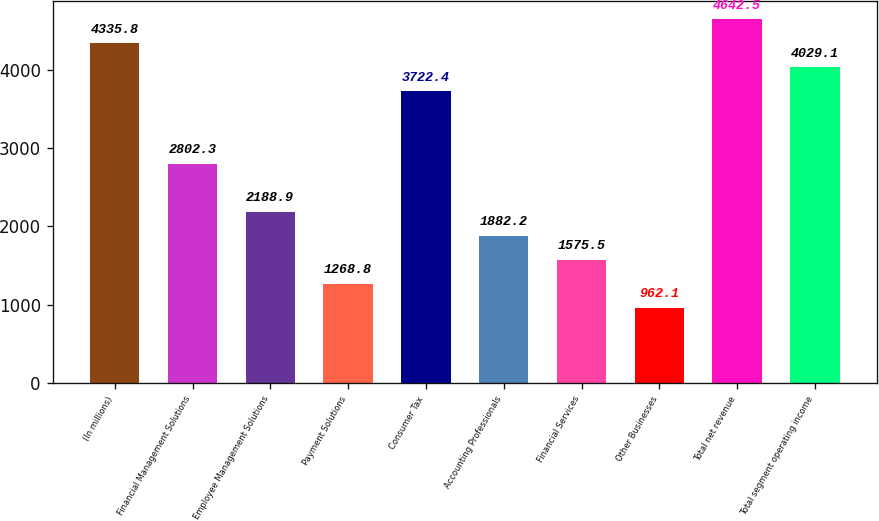Convert chart to OTSL. <chart><loc_0><loc_0><loc_500><loc_500><bar_chart><fcel>(In millions)<fcel>Financial Management Solutions<fcel>Employee Management Solutions<fcel>Payment Solutions<fcel>Consumer Tax<fcel>Accounting Professionals<fcel>Financial Services<fcel>Other Businesses<fcel>Total net revenue<fcel>Total segment operating income<nl><fcel>4335.8<fcel>2802.3<fcel>2188.9<fcel>1268.8<fcel>3722.4<fcel>1882.2<fcel>1575.5<fcel>962.1<fcel>4642.5<fcel>4029.1<nl></chart> 